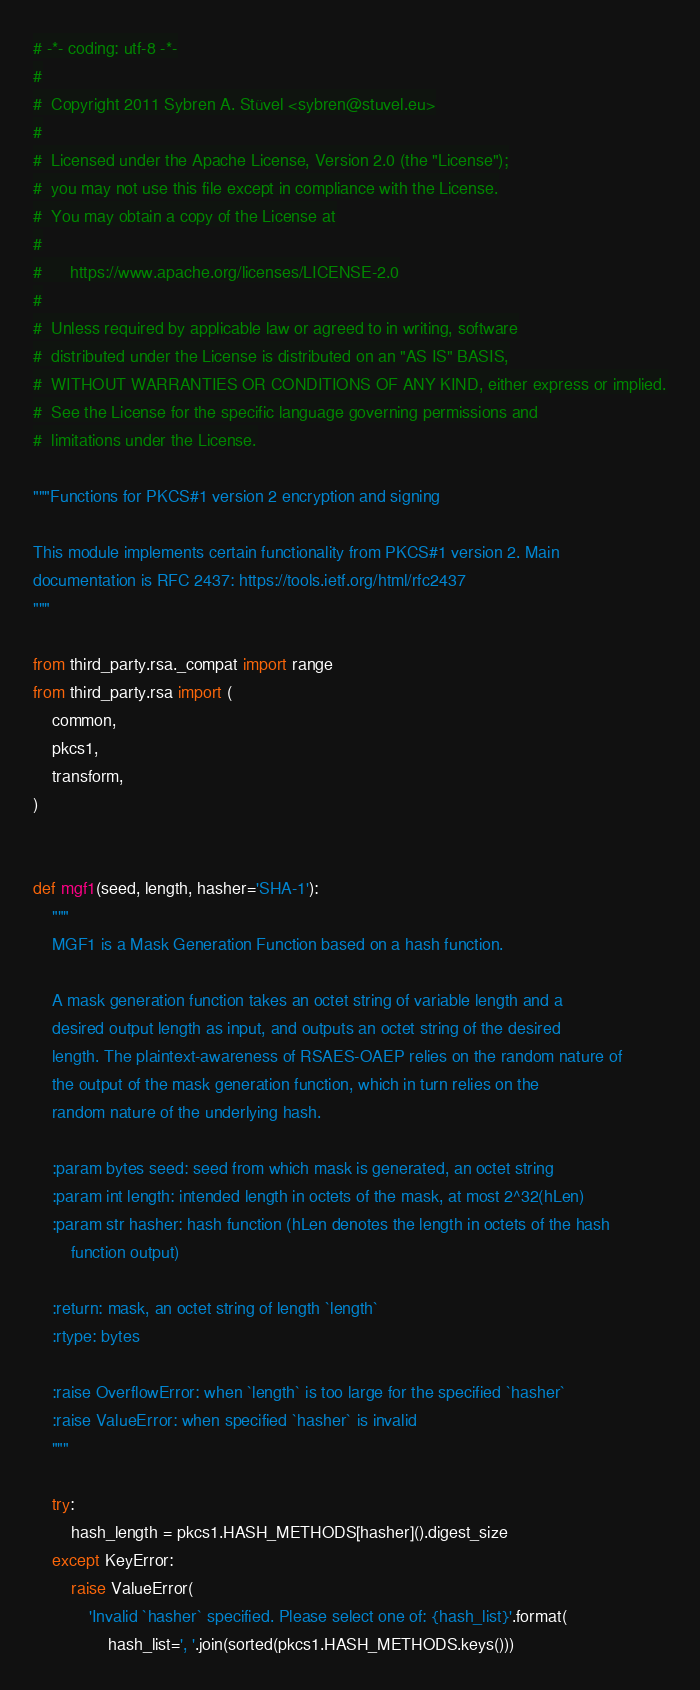<code> <loc_0><loc_0><loc_500><loc_500><_Python_># -*- coding: utf-8 -*-
#
#  Copyright 2011 Sybren A. Stüvel <sybren@stuvel.eu>
#
#  Licensed under the Apache License, Version 2.0 (the "License");
#  you may not use this file except in compliance with the License.
#  You may obtain a copy of the License at
#
#      https://www.apache.org/licenses/LICENSE-2.0
#
#  Unless required by applicable law or agreed to in writing, software
#  distributed under the License is distributed on an "AS IS" BASIS,
#  WITHOUT WARRANTIES OR CONDITIONS OF ANY KIND, either express or implied.
#  See the License for the specific language governing permissions and
#  limitations under the License.

"""Functions for PKCS#1 version 2 encryption and signing

This module implements certain functionality from PKCS#1 version 2. Main
documentation is RFC 2437: https://tools.ietf.org/html/rfc2437
"""

from third_party.rsa._compat import range
from third_party.rsa import (
    common,
    pkcs1,
    transform,
)


def mgf1(seed, length, hasher='SHA-1'):
    """
    MGF1 is a Mask Generation Function based on a hash function.

    A mask generation function takes an octet string of variable length and a
    desired output length as input, and outputs an octet string of the desired
    length. The plaintext-awareness of RSAES-OAEP relies on the random nature of
    the output of the mask generation function, which in turn relies on the
    random nature of the underlying hash.

    :param bytes seed: seed from which mask is generated, an octet string
    :param int length: intended length in octets of the mask, at most 2^32(hLen)
    :param str hasher: hash function (hLen denotes the length in octets of the hash
        function output)

    :return: mask, an octet string of length `length`
    :rtype: bytes

    :raise OverflowError: when `length` is too large for the specified `hasher`
    :raise ValueError: when specified `hasher` is invalid
    """

    try:
        hash_length = pkcs1.HASH_METHODS[hasher]().digest_size
    except KeyError:
        raise ValueError(
            'Invalid `hasher` specified. Please select one of: {hash_list}'.format(
                hash_list=', '.join(sorted(pkcs1.HASH_METHODS.keys()))</code> 